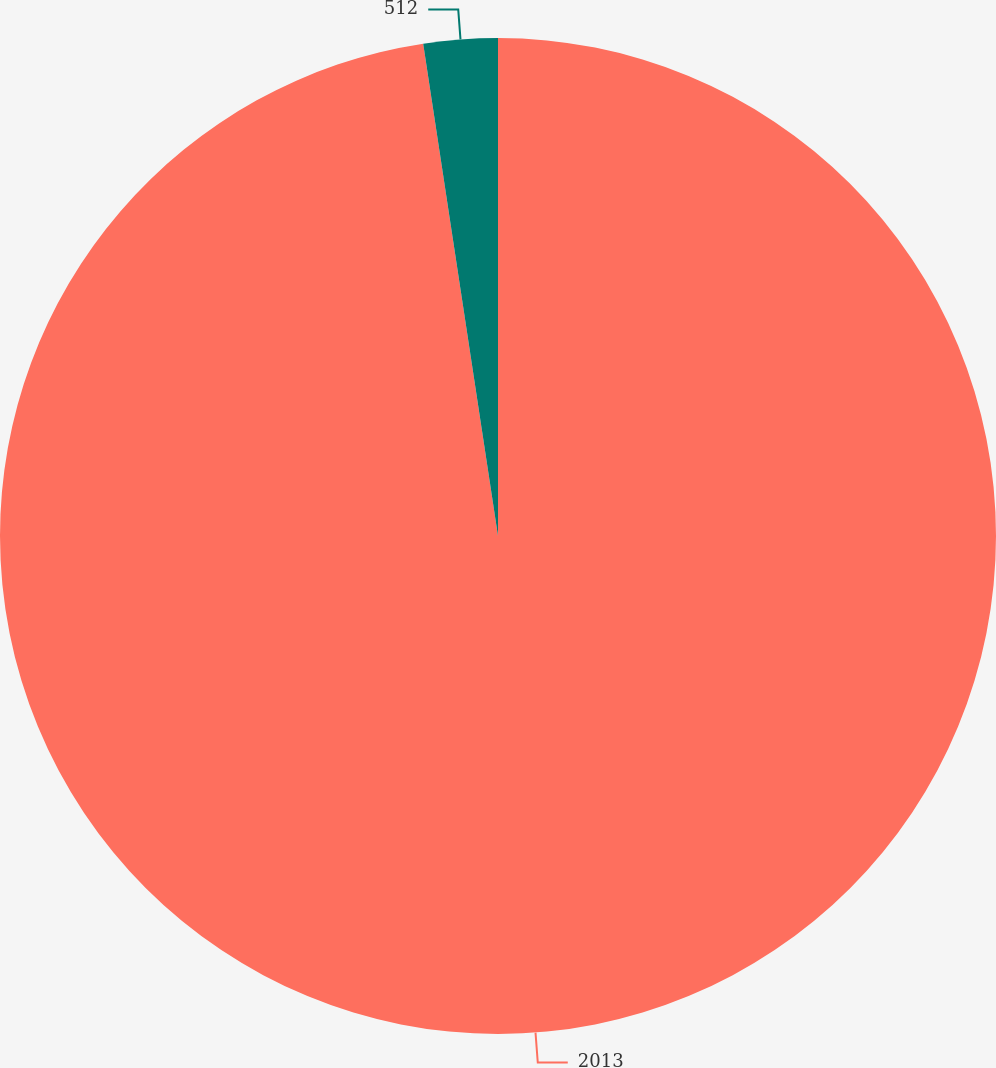Convert chart to OTSL. <chart><loc_0><loc_0><loc_500><loc_500><pie_chart><fcel>2013<fcel>512<nl><fcel>97.6%<fcel>2.4%<nl></chart> 